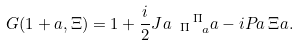Convert formula to latex. <formula><loc_0><loc_0><loc_500><loc_500>G ( 1 + \L a , \Xi ) = 1 + \frac { i } { 2 } J ^ { \L } a _ { \ \, \Pi } \, ^ { \Pi } _ { \ \, \L a } \L a - i P _ { \L } a \, \Xi ^ { \L } a .</formula> 